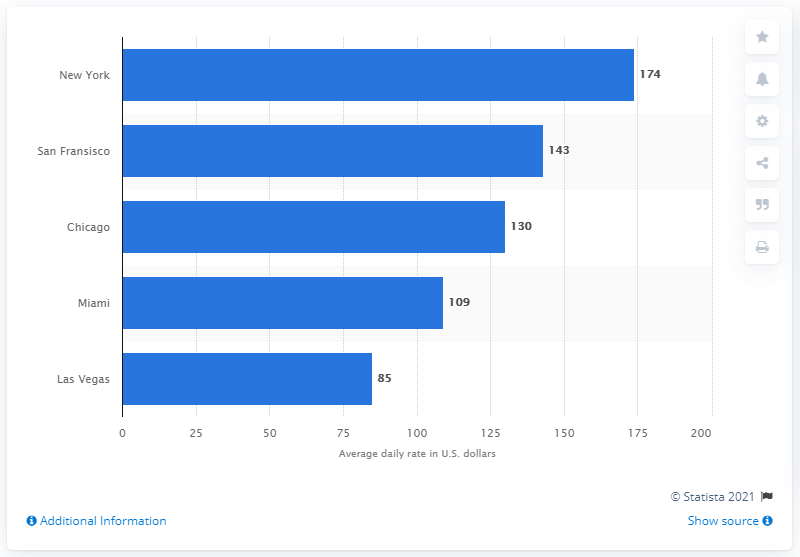List a handful of essential elements in this visual. The average price of a hotel room in New York was 174... 